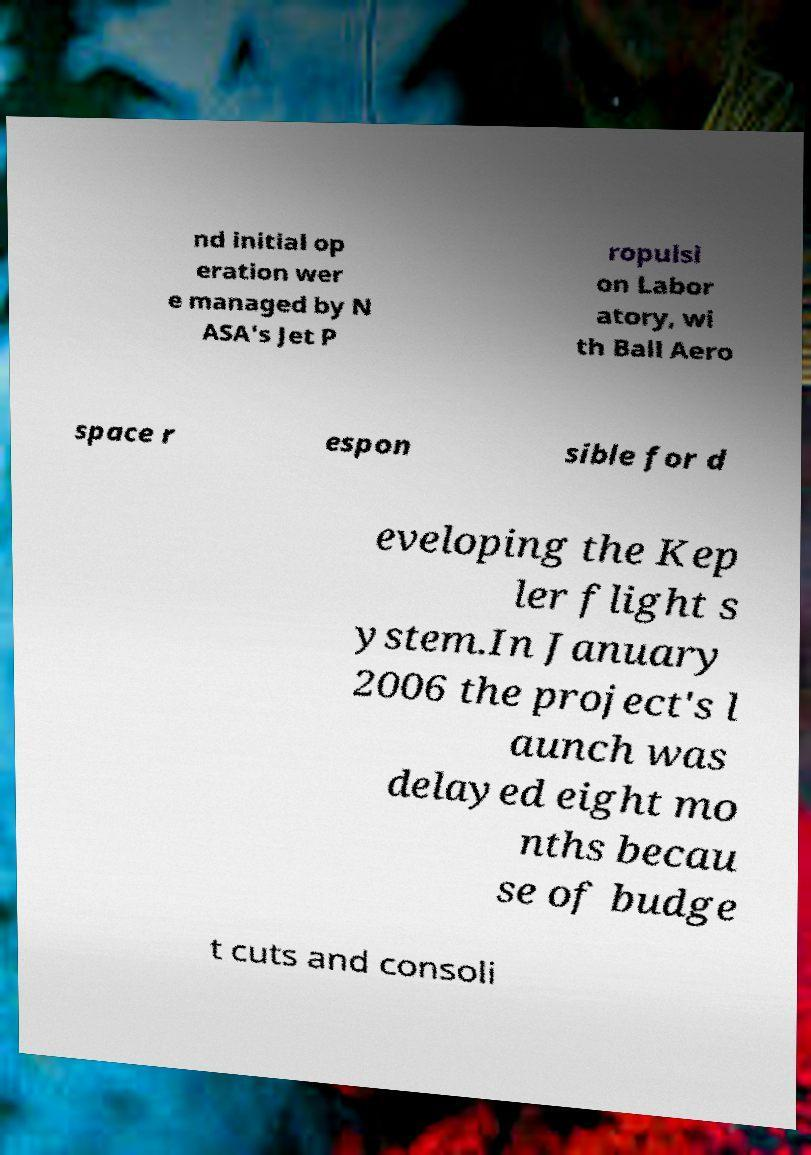For documentation purposes, I need the text within this image transcribed. Could you provide that? nd initial op eration wer e managed by N ASA's Jet P ropulsi on Labor atory, wi th Ball Aero space r espon sible for d eveloping the Kep ler flight s ystem.In January 2006 the project's l aunch was delayed eight mo nths becau se of budge t cuts and consoli 